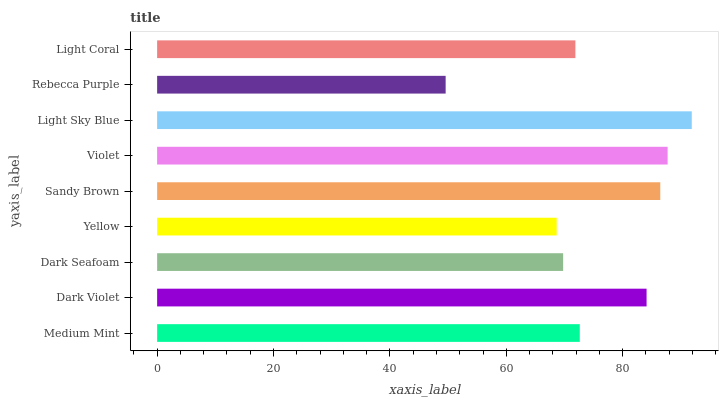Is Rebecca Purple the minimum?
Answer yes or no. Yes. Is Light Sky Blue the maximum?
Answer yes or no. Yes. Is Dark Violet the minimum?
Answer yes or no. No. Is Dark Violet the maximum?
Answer yes or no. No. Is Dark Violet greater than Medium Mint?
Answer yes or no. Yes. Is Medium Mint less than Dark Violet?
Answer yes or no. Yes. Is Medium Mint greater than Dark Violet?
Answer yes or no. No. Is Dark Violet less than Medium Mint?
Answer yes or no. No. Is Medium Mint the high median?
Answer yes or no. Yes. Is Medium Mint the low median?
Answer yes or no. Yes. Is Yellow the high median?
Answer yes or no. No. Is Dark Seafoam the low median?
Answer yes or no. No. 